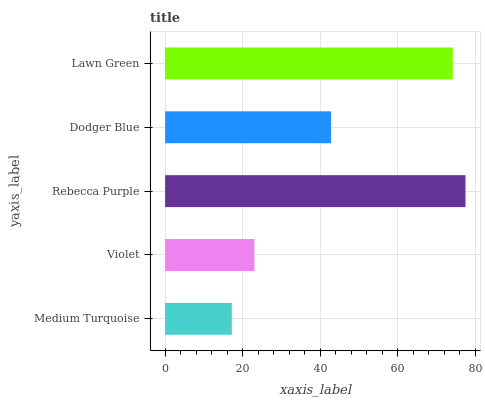Is Medium Turquoise the minimum?
Answer yes or no. Yes. Is Rebecca Purple the maximum?
Answer yes or no. Yes. Is Violet the minimum?
Answer yes or no. No. Is Violet the maximum?
Answer yes or no. No. Is Violet greater than Medium Turquoise?
Answer yes or no. Yes. Is Medium Turquoise less than Violet?
Answer yes or no. Yes. Is Medium Turquoise greater than Violet?
Answer yes or no. No. Is Violet less than Medium Turquoise?
Answer yes or no. No. Is Dodger Blue the high median?
Answer yes or no. Yes. Is Dodger Blue the low median?
Answer yes or no. Yes. Is Rebecca Purple the high median?
Answer yes or no. No. Is Violet the low median?
Answer yes or no. No. 